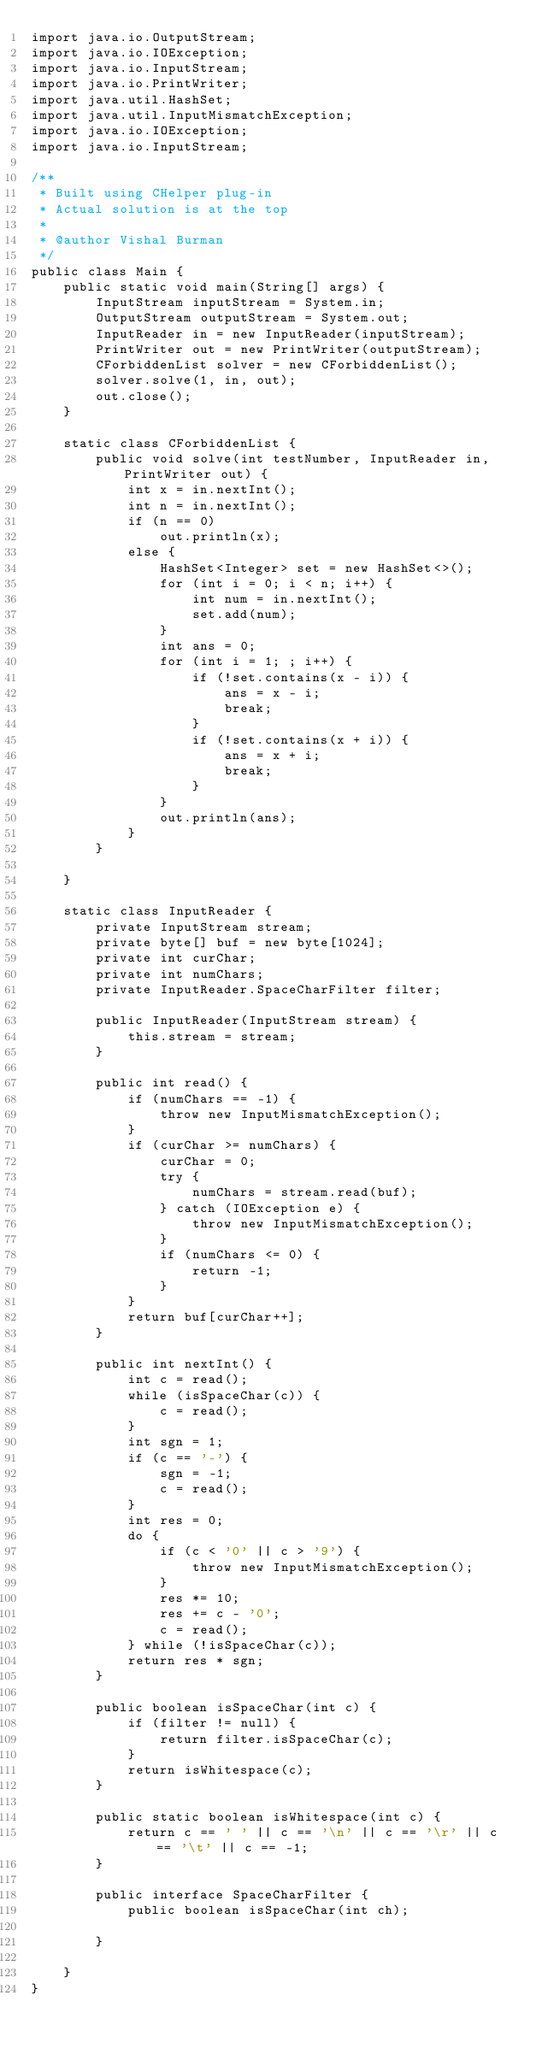Convert code to text. <code><loc_0><loc_0><loc_500><loc_500><_Java_>import java.io.OutputStream;
import java.io.IOException;
import java.io.InputStream;
import java.io.PrintWriter;
import java.util.HashSet;
import java.util.InputMismatchException;
import java.io.IOException;
import java.io.InputStream;

/**
 * Built using CHelper plug-in
 * Actual solution is at the top
 *
 * @author Vishal Burman
 */
public class Main {
    public static void main(String[] args) {
        InputStream inputStream = System.in;
        OutputStream outputStream = System.out;
        InputReader in = new InputReader(inputStream);
        PrintWriter out = new PrintWriter(outputStream);
        CForbiddenList solver = new CForbiddenList();
        solver.solve(1, in, out);
        out.close();
    }

    static class CForbiddenList {
        public void solve(int testNumber, InputReader in, PrintWriter out) {
            int x = in.nextInt();
            int n = in.nextInt();
            if (n == 0)
                out.println(x);
            else {
                HashSet<Integer> set = new HashSet<>();
                for (int i = 0; i < n; i++) {
                    int num = in.nextInt();
                    set.add(num);
                }
                int ans = 0;
                for (int i = 1; ; i++) {
                    if (!set.contains(x - i)) {
                        ans = x - i;
                        break;
                    }
                    if (!set.contains(x + i)) {
                        ans = x + i;
                        break;
                    }
                }
                out.println(ans);
            }
        }

    }

    static class InputReader {
        private InputStream stream;
        private byte[] buf = new byte[1024];
        private int curChar;
        private int numChars;
        private InputReader.SpaceCharFilter filter;

        public InputReader(InputStream stream) {
            this.stream = stream;
        }

        public int read() {
            if (numChars == -1) {
                throw new InputMismatchException();
            }
            if (curChar >= numChars) {
                curChar = 0;
                try {
                    numChars = stream.read(buf);
                } catch (IOException e) {
                    throw new InputMismatchException();
                }
                if (numChars <= 0) {
                    return -1;
                }
            }
            return buf[curChar++];
        }

        public int nextInt() {
            int c = read();
            while (isSpaceChar(c)) {
                c = read();
            }
            int sgn = 1;
            if (c == '-') {
                sgn = -1;
                c = read();
            }
            int res = 0;
            do {
                if (c < '0' || c > '9') {
                    throw new InputMismatchException();
                }
                res *= 10;
                res += c - '0';
                c = read();
            } while (!isSpaceChar(c));
            return res * sgn;
        }

        public boolean isSpaceChar(int c) {
            if (filter != null) {
                return filter.isSpaceChar(c);
            }
            return isWhitespace(c);
        }

        public static boolean isWhitespace(int c) {
            return c == ' ' || c == '\n' || c == '\r' || c == '\t' || c == -1;
        }

        public interface SpaceCharFilter {
            public boolean isSpaceChar(int ch);

        }

    }
}

</code> 